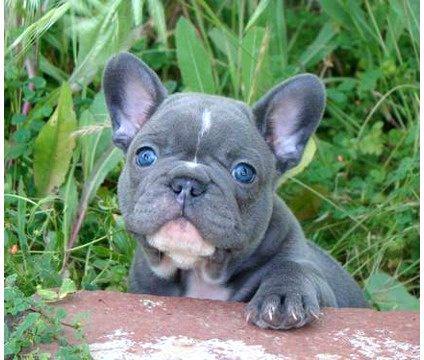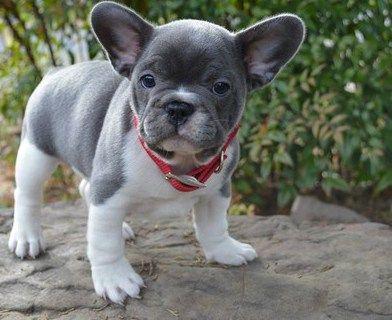The first image is the image on the left, the second image is the image on the right. Considering the images on both sides, is "One of the dogs has their tongue out at least a little bit." valid? Answer yes or no. No. The first image is the image on the left, the second image is the image on the right. Assess this claim about the two images: "One image shows a charcoal-gray big-eared pup, and one dog in the combined images wears a collar.". Correct or not? Answer yes or no. Yes. 